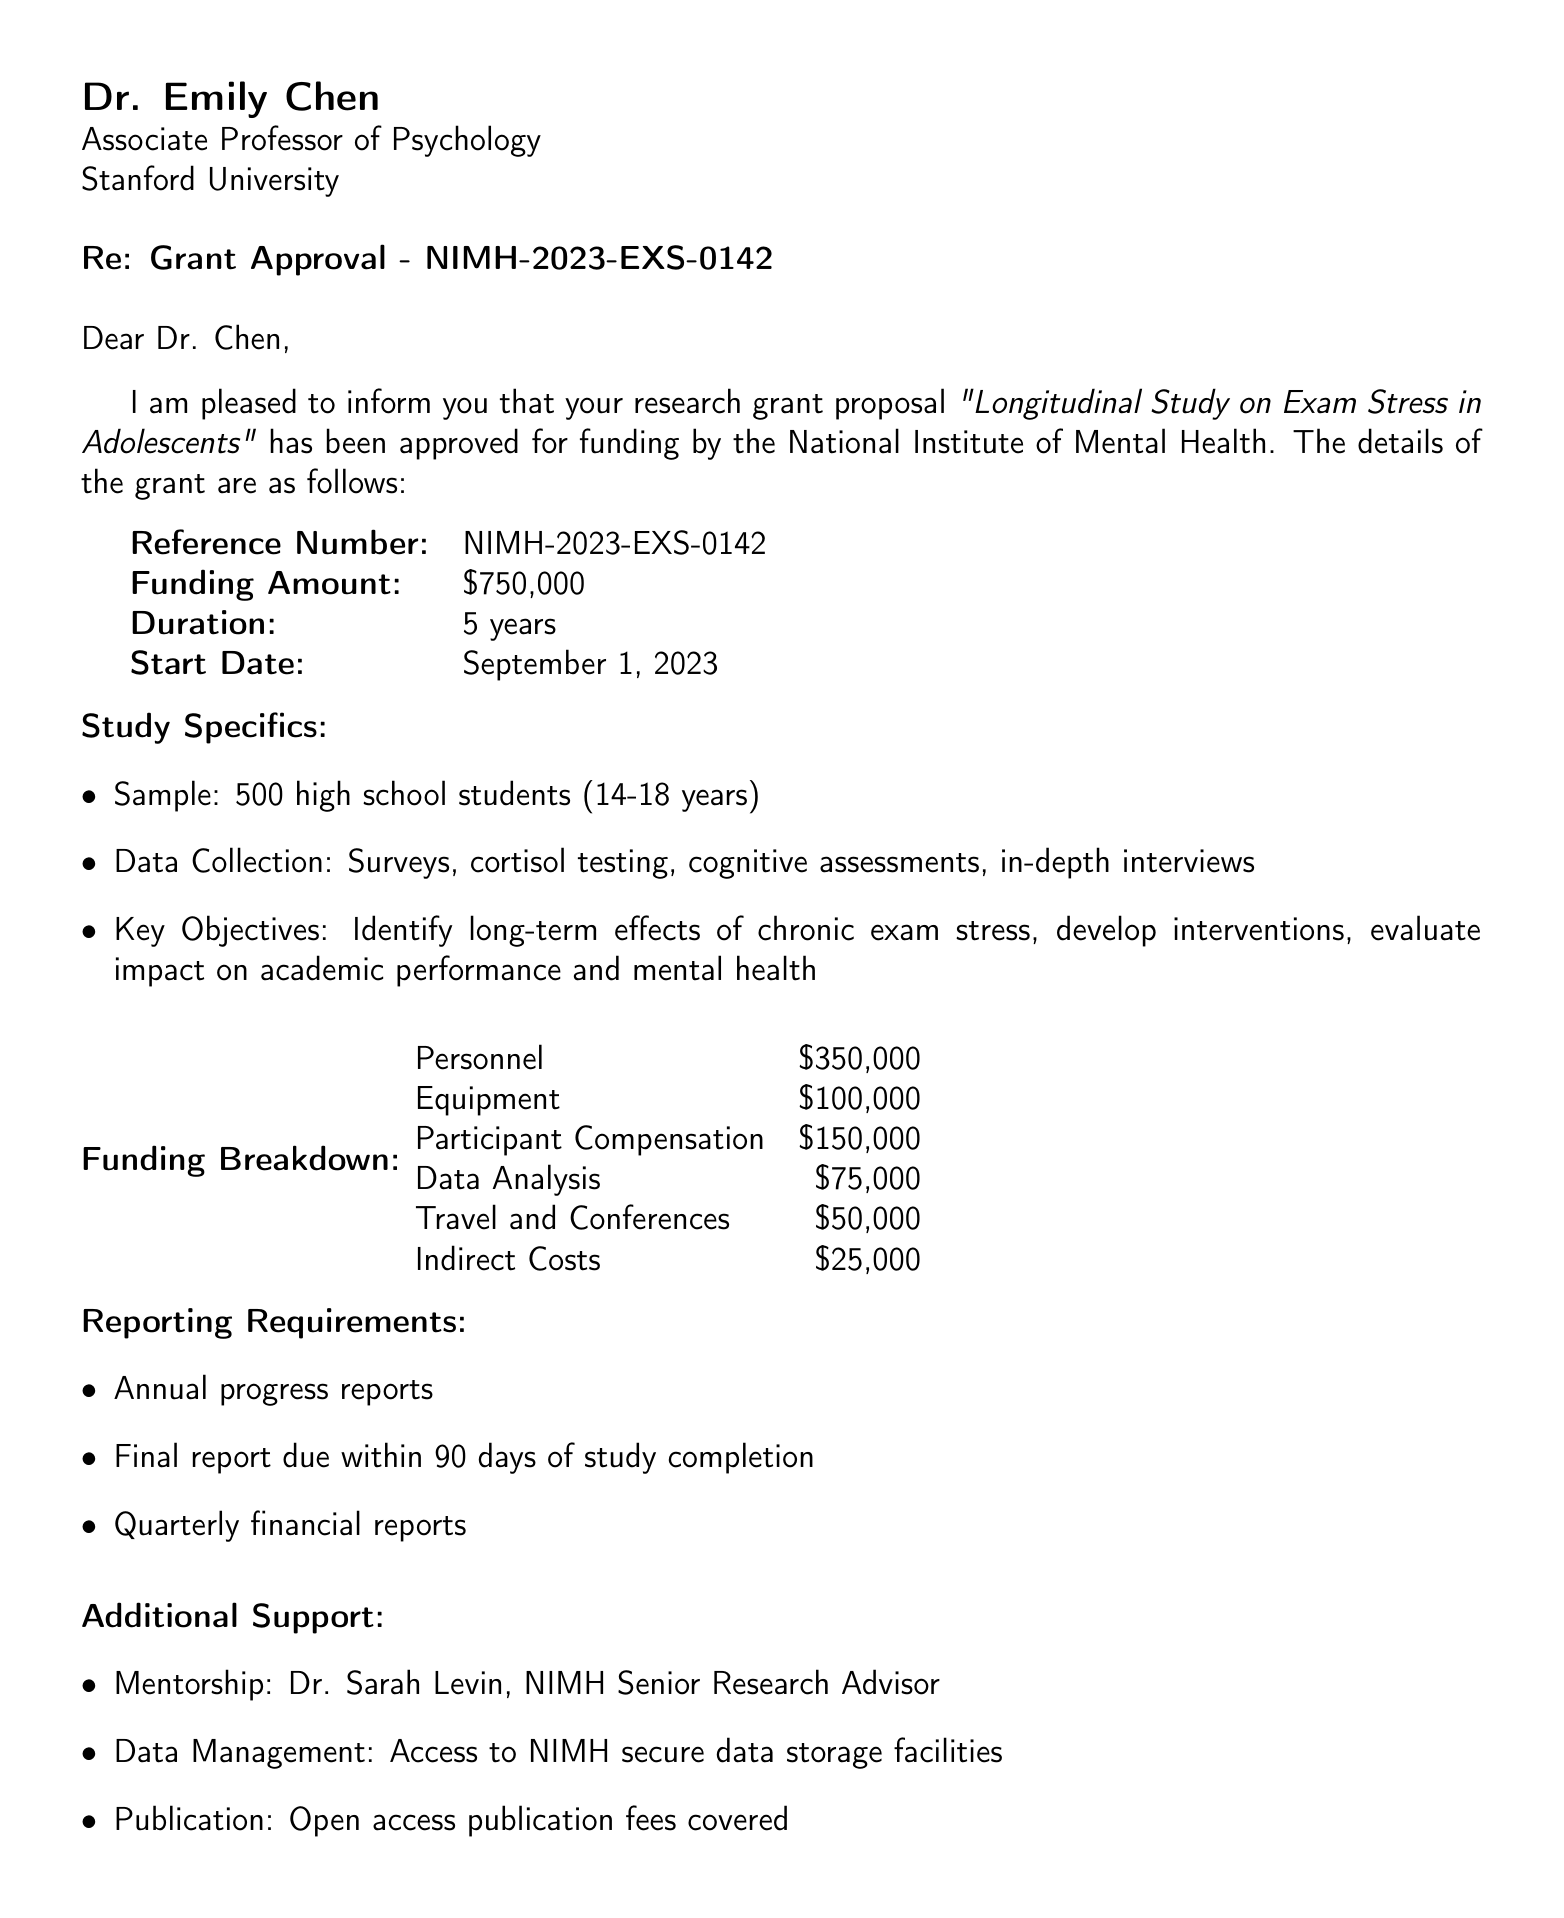what is the title of the grant? The title of the grant is clearly stated in the document as "Longitudinal Study on Exam Stress in Adolescents."
Answer: Longitudinal Study on Exam Stress in Adolescents who is the recipient of the grant? The document identifies the recipient of the grant as Dr. Emily Chen, an Associate Professor of Psychology at Stanford University.
Answer: Dr. Emily Chen what is the funding amount for the study? The funding amount for the study is listed as $750,000 in the grant details section.
Answer: $750,000 what is the age range of the sample population? The document specifies the age range of the sample population as 14-18 years.
Answer: 14-18 years how long is the duration of the study? The duration of the study is stated to be 5 years in the grant details.
Answer: 5 years what are the key objectives of the study? The document presents multiple objectives, including identifying long-term effects of chronic exam stress and developing targeted interventions for stress management.
Answer: Identify long-term effects of chronic exam stress; develop targeted interventions for stress management; evaluate impact on academic performance and mental health who is providing mentorship for the study? The document lists Dr. Sarah Levin as the mentor, identified as a Senior Research Advisor at NIMH.
Answer: Dr. Sarah Levin when is the start date of the study? The start date of the study is given in the document as September 1, 2023.
Answer: September 1, 2023 what type of reporting is required for the study? The document specifies that annual progress reports, a final report, and quarterly financial reports are required for the study.
Answer: Annual progress reports; final report due within 90 days of study completion; quarterly financial reports 